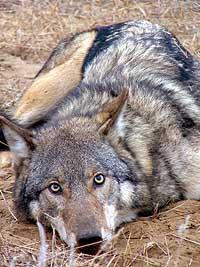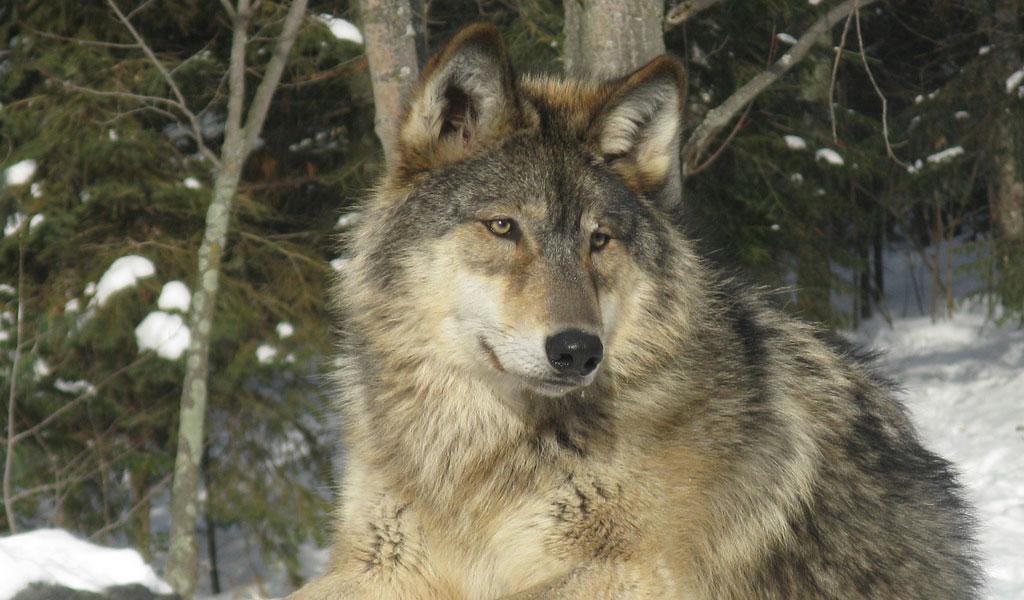The first image is the image on the left, the second image is the image on the right. Analyze the images presented: Is the assertion "the wolf on the right image is sitting" valid? Answer yes or no. Yes. 